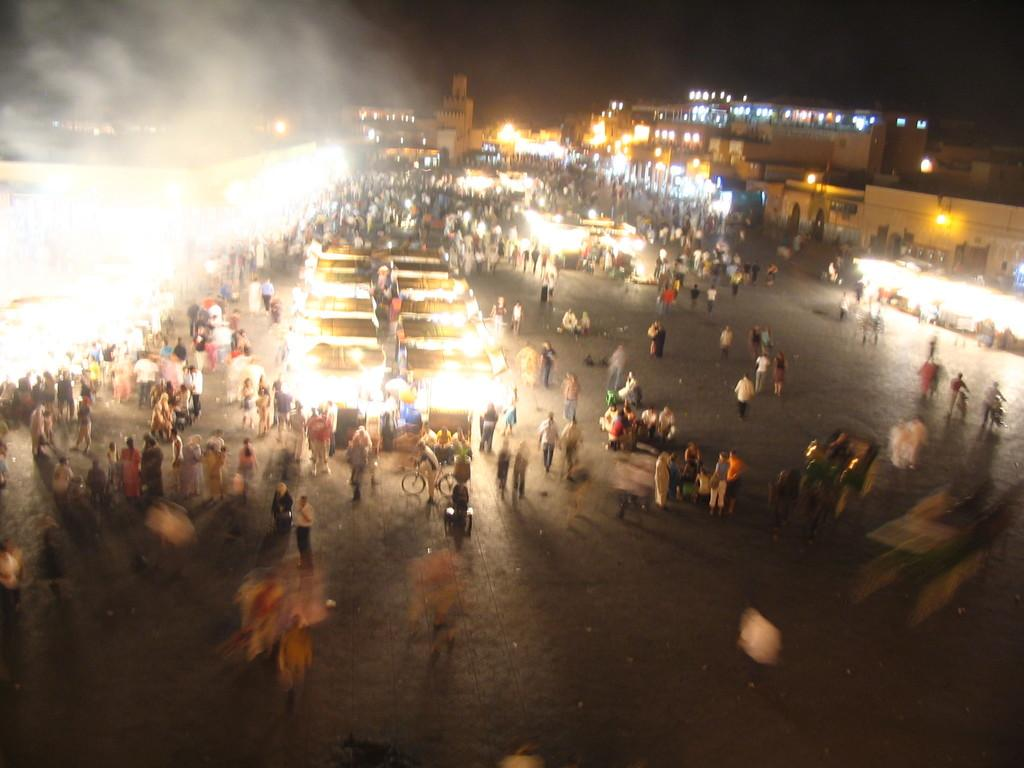Who or what can be seen in the image? There are people in the image. What type of structures are visible in the image? There are buildings in the image. Are there any illumination sources in the image? Yes, there are lights in the image. What type of cave can be seen in the image? There is no cave present in the image; it features people and buildings. What color is the father's rose in the image? There is no father or rose present in the image. 